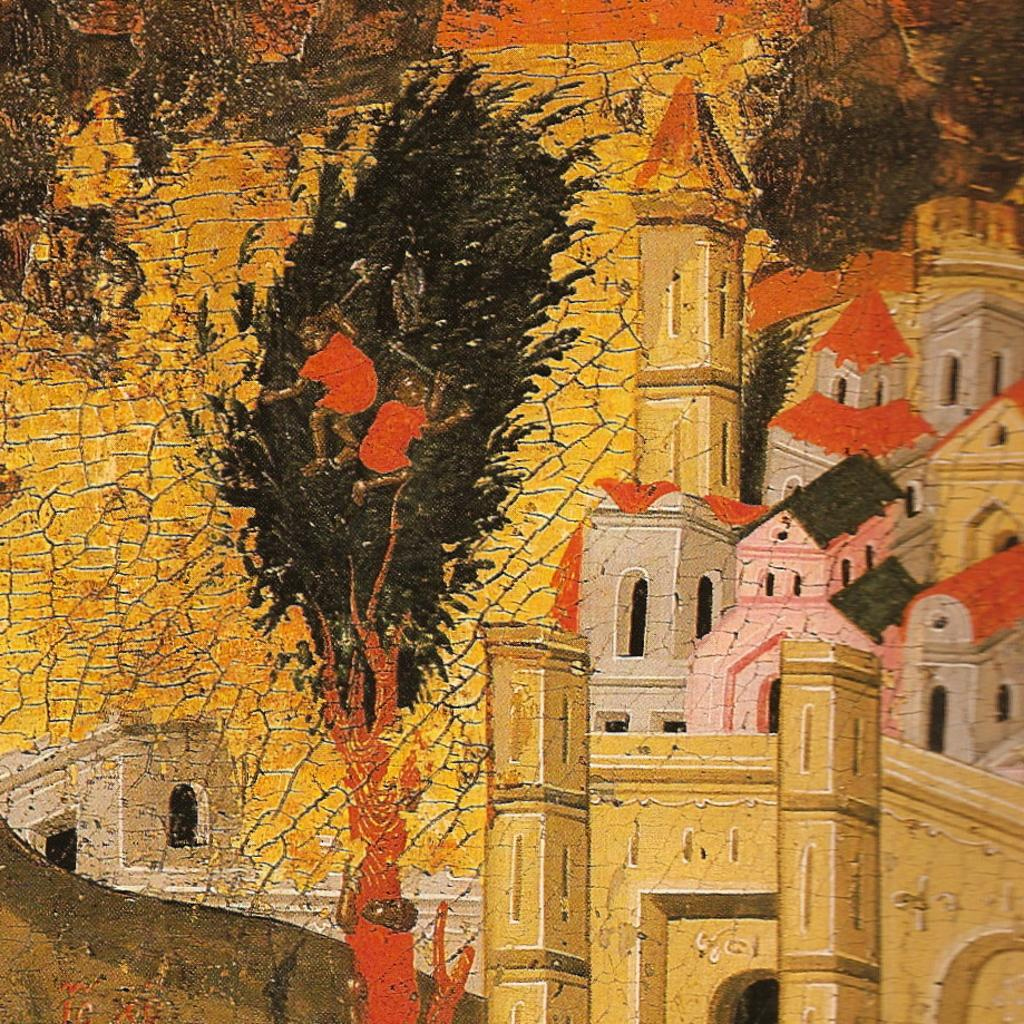What type of artwork is depicted in the image? The image is a painting. What structures can be seen in the painting? There are buildings in the painting. What type of vegetation is present in the painting? There are trees in the painting. How does the fog affect the visibility of the buildings in the painting? There is no fog present in the painting; it only features buildings and trees. 